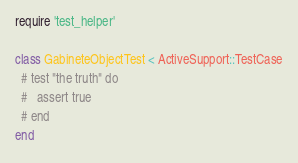Convert code to text. <code><loc_0><loc_0><loc_500><loc_500><_Ruby_>require 'test_helper'

class GabineteObjectTest < ActiveSupport::TestCase
  # test "the truth" do
  #   assert true
  # end
end
</code> 